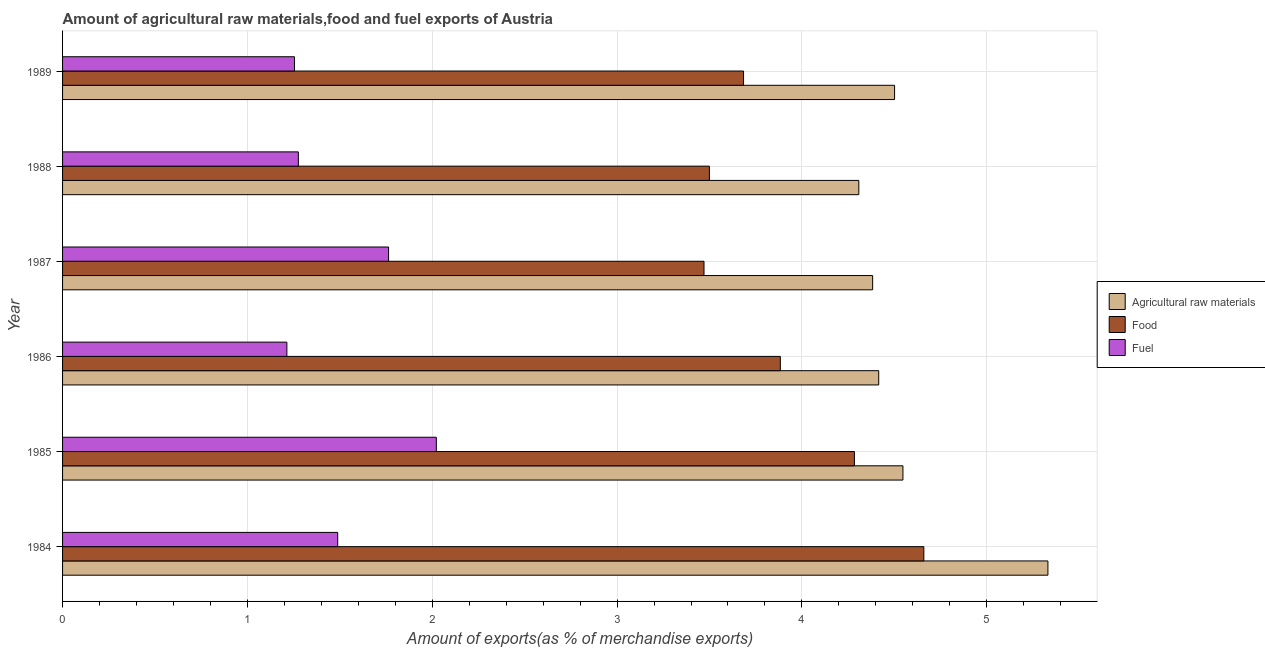How many groups of bars are there?
Offer a very short reply. 6. Are the number of bars per tick equal to the number of legend labels?
Keep it short and to the point. Yes. What is the percentage of raw materials exports in 1986?
Offer a terse response. 4.42. Across all years, what is the maximum percentage of fuel exports?
Give a very brief answer. 2.02. Across all years, what is the minimum percentage of raw materials exports?
Give a very brief answer. 4.31. In which year was the percentage of fuel exports minimum?
Make the answer very short. 1986. What is the total percentage of raw materials exports in the graph?
Make the answer very short. 27.49. What is the difference between the percentage of raw materials exports in 1988 and that in 1989?
Make the answer very short. -0.19. What is the difference between the percentage of raw materials exports in 1985 and the percentage of food exports in 1987?
Ensure brevity in your answer.  1.08. What is the average percentage of raw materials exports per year?
Provide a short and direct response. 4.58. In the year 1987, what is the difference between the percentage of food exports and percentage of raw materials exports?
Your answer should be very brief. -0.91. In how many years, is the percentage of food exports greater than 2.2 %?
Provide a short and direct response. 6. Is the percentage of raw materials exports in 1987 less than that in 1989?
Provide a succinct answer. Yes. Is the difference between the percentage of fuel exports in 1985 and 1988 greater than the difference between the percentage of raw materials exports in 1985 and 1988?
Your answer should be very brief. Yes. What is the difference between the highest and the second highest percentage of fuel exports?
Provide a short and direct response. 0.26. What is the difference between the highest and the lowest percentage of fuel exports?
Provide a succinct answer. 0.81. Is the sum of the percentage of raw materials exports in 1987 and 1988 greater than the maximum percentage of food exports across all years?
Offer a very short reply. Yes. What does the 3rd bar from the top in 1987 represents?
Make the answer very short. Agricultural raw materials. What does the 2nd bar from the bottom in 1987 represents?
Provide a short and direct response. Food. Is it the case that in every year, the sum of the percentage of raw materials exports and percentage of food exports is greater than the percentage of fuel exports?
Keep it short and to the point. Yes. How many bars are there?
Make the answer very short. 18. Are all the bars in the graph horizontal?
Give a very brief answer. Yes. How many years are there in the graph?
Your answer should be very brief. 6. Are the values on the major ticks of X-axis written in scientific E-notation?
Your answer should be compact. No. Where does the legend appear in the graph?
Offer a terse response. Center right. How many legend labels are there?
Give a very brief answer. 3. What is the title of the graph?
Your answer should be very brief. Amount of agricultural raw materials,food and fuel exports of Austria. Does "Male employers" appear as one of the legend labels in the graph?
Provide a short and direct response. No. What is the label or title of the X-axis?
Your answer should be very brief. Amount of exports(as % of merchandise exports). What is the label or title of the Y-axis?
Your answer should be compact. Year. What is the Amount of exports(as % of merchandise exports) in Agricultural raw materials in 1984?
Provide a succinct answer. 5.33. What is the Amount of exports(as % of merchandise exports) in Food in 1984?
Give a very brief answer. 4.66. What is the Amount of exports(as % of merchandise exports) of Fuel in 1984?
Give a very brief answer. 1.49. What is the Amount of exports(as % of merchandise exports) in Agricultural raw materials in 1985?
Ensure brevity in your answer.  4.55. What is the Amount of exports(as % of merchandise exports) of Food in 1985?
Ensure brevity in your answer.  4.28. What is the Amount of exports(as % of merchandise exports) in Fuel in 1985?
Provide a short and direct response. 2.02. What is the Amount of exports(as % of merchandise exports) in Agricultural raw materials in 1986?
Your response must be concise. 4.42. What is the Amount of exports(as % of merchandise exports) in Food in 1986?
Make the answer very short. 3.88. What is the Amount of exports(as % of merchandise exports) in Fuel in 1986?
Offer a terse response. 1.21. What is the Amount of exports(as % of merchandise exports) of Agricultural raw materials in 1987?
Your answer should be compact. 4.38. What is the Amount of exports(as % of merchandise exports) in Food in 1987?
Provide a short and direct response. 3.47. What is the Amount of exports(as % of merchandise exports) in Fuel in 1987?
Give a very brief answer. 1.76. What is the Amount of exports(as % of merchandise exports) of Agricultural raw materials in 1988?
Ensure brevity in your answer.  4.31. What is the Amount of exports(as % of merchandise exports) in Food in 1988?
Offer a terse response. 3.5. What is the Amount of exports(as % of merchandise exports) of Fuel in 1988?
Keep it short and to the point. 1.28. What is the Amount of exports(as % of merchandise exports) in Agricultural raw materials in 1989?
Give a very brief answer. 4.5. What is the Amount of exports(as % of merchandise exports) in Food in 1989?
Offer a very short reply. 3.68. What is the Amount of exports(as % of merchandise exports) in Fuel in 1989?
Offer a terse response. 1.25. Across all years, what is the maximum Amount of exports(as % of merchandise exports) in Agricultural raw materials?
Keep it short and to the point. 5.33. Across all years, what is the maximum Amount of exports(as % of merchandise exports) in Food?
Your answer should be very brief. 4.66. Across all years, what is the maximum Amount of exports(as % of merchandise exports) of Fuel?
Your answer should be compact. 2.02. Across all years, what is the minimum Amount of exports(as % of merchandise exports) of Agricultural raw materials?
Keep it short and to the point. 4.31. Across all years, what is the minimum Amount of exports(as % of merchandise exports) of Food?
Ensure brevity in your answer.  3.47. Across all years, what is the minimum Amount of exports(as % of merchandise exports) of Fuel?
Make the answer very short. 1.21. What is the total Amount of exports(as % of merchandise exports) of Agricultural raw materials in the graph?
Ensure brevity in your answer.  27.49. What is the total Amount of exports(as % of merchandise exports) in Food in the graph?
Your response must be concise. 23.48. What is the total Amount of exports(as % of merchandise exports) in Fuel in the graph?
Your answer should be very brief. 9.02. What is the difference between the Amount of exports(as % of merchandise exports) in Agricultural raw materials in 1984 and that in 1985?
Provide a succinct answer. 0.78. What is the difference between the Amount of exports(as % of merchandise exports) of Food in 1984 and that in 1985?
Make the answer very short. 0.38. What is the difference between the Amount of exports(as % of merchandise exports) in Fuel in 1984 and that in 1985?
Make the answer very short. -0.53. What is the difference between the Amount of exports(as % of merchandise exports) in Agricultural raw materials in 1984 and that in 1986?
Ensure brevity in your answer.  0.92. What is the difference between the Amount of exports(as % of merchandise exports) in Food in 1984 and that in 1986?
Provide a short and direct response. 0.78. What is the difference between the Amount of exports(as % of merchandise exports) of Fuel in 1984 and that in 1986?
Keep it short and to the point. 0.28. What is the difference between the Amount of exports(as % of merchandise exports) in Agricultural raw materials in 1984 and that in 1987?
Your response must be concise. 0.95. What is the difference between the Amount of exports(as % of merchandise exports) of Food in 1984 and that in 1987?
Provide a short and direct response. 1.19. What is the difference between the Amount of exports(as % of merchandise exports) in Fuel in 1984 and that in 1987?
Offer a terse response. -0.28. What is the difference between the Amount of exports(as % of merchandise exports) in Agricultural raw materials in 1984 and that in 1988?
Your answer should be very brief. 1.02. What is the difference between the Amount of exports(as % of merchandise exports) of Food in 1984 and that in 1988?
Provide a short and direct response. 1.16. What is the difference between the Amount of exports(as % of merchandise exports) in Fuel in 1984 and that in 1988?
Your response must be concise. 0.21. What is the difference between the Amount of exports(as % of merchandise exports) of Agricultural raw materials in 1984 and that in 1989?
Provide a short and direct response. 0.83. What is the difference between the Amount of exports(as % of merchandise exports) in Food in 1984 and that in 1989?
Offer a terse response. 0.98. What is the difference between the Amount of exports(as % of merchandise exports) in Fuel in 1984 and that in 1989?
Your answer should be compact. 0.23. What is the difference between the Amount of exports(as % of merchandise exports) of Agricultural raw materials in 1985 and that in 1986?
Provide a short and direct response. 0.13. What is the difference between the Amount of exports(as % of merchandise exports) of Food in 1985 and that in 1986?
Provide a succinct answer. 0.4. What is the difference between the Amount of exports(as % of merchandise exports) in Fuel in 1985 and that in 1986?
Offer a terse response. 0.81. What is the difference between the Amount of exports(as % of merchandise exports) in Agricultural raw materials in 1985 and that in 1987?
Your answer should be very brief. 0.16. What is the difference between the Amount of exports(as % of merchandise exports) in Food in 1985 and that in 1987?
Your answer should be very brief. 0.81. What is the difference between the Amount of exports(as % of merchandise exports) in Fuel in 1985 and that in 1987?
Provide a short and direct response. 0.26. What is the difference between the Amount of exports(as % of merchandise exports) of Agricultural raw materials in 1985 and that in 1988?
Provide a succinct answer. 0.24. What is the difference between the Amount of exports(as % of merchandise exports) in Food in 1985 and that in 1988?
Your answer should be compact. 0.78. What is the difference between the Amount of exports(as % of merchandise exports) of Fuel in 1985 and that in 1988?
Keep it short and to the point. 0.75. What is the difference between the Amount of exports(as % of merchandise exports) in Agricultural raw materials in 1985 and that in 1989?
Provide a short and direct response. 0.05. What is the difference between the Amount of exports(as % of merchandise exports) in Food in 1985 and that in 1989?
Keep it short and to the point. 0.6. What is the difference between the Amount of exports(as % of merchandise exports) of Fuel in 1985 and that in 1989?
Offer a terse response. 0.77. What is the difference between the Amount of exports(as % of merchandise exports) of Agricultural raw materials in 1986 and that in 1987?
Give a very brief answer. 0.03. What is the difference between the Amount of exports(as % of merchandise exports) of Food in 1986 and that in 1987?
Offer a very short reply. 0.41. What is the difference between the Amount of exports(as % of merchandise exports) of Fuel in 1986 and that in 1987?
Your answer should be very brief. -0.55. What is the difference between the Amount of exports(as % of merchandise exports) of Agricultural raw materials in 1986 and that in 1988?
Keep it short and to the point. 0.11. What is the difference between the Amount of exports(as % of merchandise exports) in Food in 1986 and that in 1988?
Ensure brevity in your answer.  0.38. What is the difference between the Amount of exports(as % of merchandise exports) in Fuel in 1986 and that in 1988?
Give a very brief answer. -0.06. What is the difference between the Amount of exports(as % of merchandise exports) in Agricultural raw materials in 1986 and that in 1989?
Your answer should be compact. -0.09. What is the difference between the Amount of exports(as % of merchandise exports) in Food in 1986 and that in 1989?
Your answer should be very brief. 0.2. What is the difference between the Amount of exports(as % of merchandise exports) of Fuel in 1986 and that in 1989?
Your answer should be very brief. -0.04. What is the difference between the Amount of exports(as % of merchandise exports) in Agricultural raw materials in 1987 and that in 1988?
Your response must be concise. 0.07. What is the difference between the Amount of exports(as % of merchandise exports) in Food in 1987 and that in 1988?
Make the answer very short. -0.03. What is the difference between the Amount of exports(as % of merchandise exports) in Fuel in 1987 and that in 1988?
Your answer should be compact. 0.49. What is the difference between the Amount of exports(as % of merchandise exports) of Agricultural raw materials in 1987 and that in 1989?
Offer a very short reply. -0.12. What is the difference between the Amount of exports(as % of merchandise exports) in Food in 1987 and that in 1989?
Provide a short and direct response. -0.21. What is the difference between the Amount of exports(as % of merchandise exports) in Fuel in 1987 and that in 1989?
Offer a very short reply. 0.51. What is the difference between the Amount of exports(as % of merchandise exports) of Agricultural raw materials in 1988 and that in 1989?
Keep it short and to the point. -0.19. What is the difference between the Amount of exports(as % of merchandise exports) of Food in 1988 and that in 1989?
Keep it short and to the point. -0.18. What is the difference between the Amount of exports(as % of merchandise exports) in Fuel in 1988 and that in 1989?
Ensure brevity in your answer.  0.02. What is the difference between the Amount of exports(as % of merchandise exports) in Agricultural raw materials in 1984 and the Amount of exports(as % of merchandise exports) in Food in 1985?
Offer a terse response. 1.05. What is the difference between the Amount of exports(as % of merchandise exports) of Agricultural raw materials in 1984 and the Amount of exports(as % of merchandise exports) of Fuel in 1985?
Your response must be concise. 3.31. What is the difference between the Amount of exports(as % of merchandise exports) in Food in 1984 and the Amount of exports(as % of merchandise exports) in Fuel in 1985?
Give a very brief answer. 2.64. What is the difference between the Amount of exports(as % of merchandise exports) of Agricultural raw materials in 1984 and the Amount of exports(as % of merchandise exports) of Food in 1986?
Keep it short and to the point. 1.45. What is the difference between the Amount of exports(as % of merchandise exports) of Agricultural raw materials in 1984 and the Amount of exports(as % of merchandise exports) of Fuel in 1986?
Provide a succinct answer. 4.12. What is the difference between the Amount of exports(as % of merchandise exports) in Food in 1984 and the Amount of exports(as % of merchandise exports) in Fuel in 1986?
Give a very brief answer. 3.45. What is the difference between the Amount of exports(as % of merchandise exports) in Agricultural raw materials in 1984 and the Amount of exports(as % of merchandise exports) in Food in 1987?
Offer a terse response. 1.86. What is the difference between the Amount of exports(as % of merchandise exports) in Agricultural raw materials in 1984 and the Amount of exports(as % of merchandise exports) in Fuel in 1987?
Your answer should be very brief. 3.57. What is the difference between the Amount of exports(as % of merchandise exports) in Food in 1984 and the Amount of exports(as % of merchandise exports) in Fuel in 1987?
Give a very brief answer. 2.9. What is the difference between the Amount of exports(as % of merchandise exports) in Agricultural raw materials in 1984 and the Amount of exports(as % of merchandise exports) in Food in 1988?
Give a very brief answer. 1.83. What is the difference between the Amount of exports(as % of merchandise exports) in Agricultural raw materials in 1984 and the Amount of exports(as % of merchandise exports) in Fuel in 1988?
Your response must be concise. 4.06. What is the difference between the Amount of exports(as % of merchandise exports) of Food in 1984 and the Amount of exports(as % of merchandise exports) of Fuel in 1988?
Offer a very short reply. 3.38. What is the difference between the Amount of exports(as % of merchandise exports) in Agricultural raw materials in 1984 and the Amount of exports(as % of merchandise exports) in Food in 1989?
Keep it short and to the point. 1.65. What is the difference between the Amount of exports(as % of merchandise exports) in Agricultural raw materials in 1984 and the Amount of exports(as % of merchandise exports) in Fuel in 1989?
Ensure brevity in your answer.  4.08. What is the difference between the Amount of exports(as % of merchandise exports) of Food in 1984 and the Amount of exports(as % of merchandise exports) of Fuel in 1989?
Provide a short and direct response. 3.4. What is the difference between the Amount of exports(as % of merchandise exports) in Agricultural raw materials in 1985 and the Amount of exports(as % of merchandise exports) in Food in 1986?
Make the answer very short. 0.66. What is the difference between the Amount of exports(as % of merchandise exports) of Agricultural raw materials in 1985 and the Amount of exports(as % of merchandise exports) of Fuel in 1986?
Your answer should be very brief. 3.33. What is the difference between the Amount of exports(as % of merchandise exports) of Food in 1985 and the Amount of exports(as % of merchandise exports) of Fuel in 1986?
Offer a terse response. 3.07. What is the difference between the Amount of exports(as % of merchandise exports) of Agricultural raw materials in 1985 and the Amount of exports(as % of merchandise exports) of Food in 1987?
Give a very brief answer. 1.08. What is the difference between the Amount of exports(as % of merchandise exports) of Agricultural raw materials in 1985 and the Amount of exports(as % of merchandise exports) of Fuel in 1987?
Your answer should be very brief. 2.78. What is the difference between the Amount of exports(as % of merchandise exports) of Food in 1985 and the Amount of exports(as % of merchandise exports) of Fuel in 1987?
Your answer should be very brief. 2.52. What is the difference between the Amount of exports(as % of merchandise exports) of Agricultural raw materials in 1985 and the Amount of exports(as % of merchandise exports) of Food in 1988?
Your answer should be compact. 1.05. What is the difference between the Amount of exports(as % of merchandise exports) in Agricultural raw materials in 1985 and the Amount of exports(as % of merchandise exports) in Fuel in 1988?
Your answer should be compact. 3.27. What is the difference between the Amount of exports(as % of merchandise exports) in Food in 1985 and the Amount of exports(as % of merchandise exports) in Fuel in 1988?
Give a very brief answer. 3.01. What is the difference between the Amount of exports(as % of merchandise exports) in Agricultural raw materials in 1985 and the Amount of exports(as % of merchandise exports) in Food in 1989?
Your response must be concise. 0.86. What is the difference between the Amount of exports(as % of merchandise exports) in Agricultural raw materials in 1985 and the Amount of exports(as % of merchandise exports) in Fuel in 1989?
Make the answer very short. 3.29. What is the difference between the Amount of exports(as % of merchandise exports) of Food in 1985 and the Amount of exports(as % of merchandise exports) of Fuel in 1989?
Your response must be concise. 3.03. What is the difference between the Amount of exports(as % of merchandise exports) in Agricultural raw materials in 1986 and the Amount of exports(as % of merchandise exports) in Food in 1987?
Ensure brevity in your answer.  0.95. What is the difference between the Amount of exports(as % of merchandise exports) of Agricultural raw materials in 1986 and the Amount of exports(as % of merchandise exports) of Fuel in 1987?
Ensure brevity in your answer.  2.65. What is the difference between the Amount of exports(as % of merchandise exports) of Food in 1986 and the Amount of exports(as % of merchandise exports) of Fuel in 1987?
Your answer should be compact. 2.12. What is the difference between the Amount of exports(as % of merchandise exports) of Agricultural raw materials in 1986 and the Amount of exports(as % of merchandise exports) of Food in 1988?
Keep it short and to the point. 0.92. What is the difference between the Amount of exports(as % of merchandise exports) of Agricultural raw materials in 1986 and the Amount of exports(as % of merchandise exports) of Fuel in 1988?
Give a very brief answer. 3.14. What is the difference between the Amount of exports(as % of merchandise exports) in Food in 1986 and the Amount of exports(as % of merchandise exports) in Fuel in 1988?
Offer a terse response. 2.61. What is the difference between the Amount of exports(as % of merchandise exports) of Agricultural raw materials in 1986 and the Amount of exports(as % of merchandise exports) of Food in 1989?
Give a very brief answer. 0.73. What is the difference between the Amount of exports(as % of merchandise exports) of Agricultural raw materials in 1986 and the Amount of exports(as % of merchandise exports) of Fuel in 1989?
Make the answer very short. 3.16. What is the difference between the Amount of exports(as % of merchandise exports) of Food in 1986 and the Amount of exports(as % of merchandise exports) of Fuel in 1989?
Provide a short and direct response. 2.63. What is the difference between the Amount of exports(as % of merchandise exports) in Agricultural raw materials in 1987 and the Amount of exports(as % of merchandise exports) in Food in 1988?
Provide a short and direct response. 0.88. What is the difference between the Amount of exports(as % of merchandise exports) of Agricultural raw materials in 1987 and the Amount of exports(as % of merchandise exports) of Fuel in 1988?
Offer a very short reply. 3.11. What is the difference between the Amount of exports(as % of merchandise exports) of Food in 1987 and the Amount of exports(as % of merchandise exports) of Fuel in 1988?
Make the answer very short. 2.19. What is the difference between the Amount of exports(as % of merchandise exports) in Agricultural raw materials in 1987 and the Amount of exports(as % of merchandise exports) in Food in 1989?
Your answer should be compact. 0.7. What is the difference between the Amount of exports(as % of merchandise exports) of Agricultural raw materials in 1987 and the Amount of exports(as % of merchandise exports) of Fuel in 1989?
Your response must be concise. 3.13. What is the difference between the Amount of exports(as % of merchandise exports) of Food in 1987 and the Amount of exports(as % of merchandise exports) of Fuel in 1989?
Provide a short and direct response. 2.22. What is the difference between the Amount of exports(as % of merchandise exports) of Agricultural raw materials in 1988 and the Amount of exports(as % of merchandise exports) of Food in 1989?
Make the answer very short. 0.62. What is the difference between the Amount of exports(as % of merchandise exports) in Agricultural raw materials in 1988 and the Amount of exports(as % of merchandise exports) in Fuel in 1989?
Offer a terse response. 3.05. What is the difference between the Amount of exports(as % of merchandise exports) in Food in 1988 and the Amount of exports(as % of merchandise exports) in Fuel in 1989?
Give a very brief answer. 2.24. What is the average Amount of exports(as % of merchandise exports) in Agricultural raw materials per year?
Make the answer very short. 4.58. What is the average Amount of exports(as % of merchandise exports) of Food per year?
Offer a terse response. 3.91. What is the average Amount of exports(as % of merchandise exports) in Fuel per year?
Give a very brief answer. 1.5. In the year 1984, what is the difference between the Amount of exports(as % of merchandise exports) of Agricultural raw materials and Amount of exports(as % of merchandise exports) of Food?
Offer a very short reply. 0.67. In the year 1984, what is the difference between the Amount of exports(as % of merchandise exports) of Agricultural raw materials and Amount of exports(as % of merchandise exports) of Fuel?
Offer a terse response. 3.84. In the year 1984, what is the difference between the Amount of exports(as % of merchandise exports) in Food and Amount of exports(as % of merchandise exports) in Fuel?
Offer a very short reply. 3.17. In the year 1985, what is the difference between the Amount of exports(as % of merchandise exports) in Agricultural raw materials and Amount of exports(as % of merchandise exports) in Food?
Offer a very short reply. 0.26. In the year 1985, what is the difference between the Amount of exports(as % of merchandise exports) of Agricultural raw materials and Amount of exports(as % of merchandise exports) of Fuel?
Provide a succinct answer. 2.52. In the year 1985, what is the difference between the Amount of exports(as % of merchandise exports) in Food and Amount of exports(as % of merchandise exports) in Fuel?
Give a very brief answer. 2.26. In the year 1986, what is the difference between the Amount of exports(as % of merchandise exports) of Agricultural raw materials and Amount of exports(as % of merchandise exports) of Food?
Offer a very short reply. 0.53. In the year 1986, what is the difference between the Amount of exports(as % of merchandise exports) of Agricultural raw materials and Amount of exports(as % of merchandise exports) of Fuel?
Make the answer very short. 3.2. In the year 1986, what is the difference between the Amount of exports(as % of merchandise exports) of Food and Amount of exports(as % of merchandise exports) of Fuel?
Offer a terse response. 2.67. In the year 1987, what is the difference between the Amount of exports(as % of merchandise exports) in Agricultural raw materials and Amount of exports(as % of merchandise exports) in Food?
Give a very brief answer. 0.91. In the year 1987, what is the difference between the Amount of exports(as % of merchandise exports) in Agricultural raw materials and Amount of exports(as % of merchandise exports) in Fuel?
Provide a short and direct response. 2.62. In the year 1987, what is the difference between the Amount of exports(as % of merchandise exports) in Food and Amount of exports(as % of merchandise exports) in Fuel?
Make the answer very short. 1.71. In the year 1988, what is the difference between the Amount of exports(as % of merchandise exports) of Agricultural raw materials and Amount of exports(as % of merchandise exports) of Food?
Offer a terse response. 0.81. In the year 1988, what is the difference between the Amount of exports(as % of merchandise exports) of Agricultural raw materials and Amount of exports(as % of merchandise exports) of Fuel?
Offer a terse response. 3.03. In the year 1988, what is the difference between the Amount of exports(as % of merchandise exports) in Food and Amount of exports(as % of merchandise exports) in Fuel?
Your answer should be compact. 2.22. In the year 1989, what is the difference between the Amount of exports(as % of merchandise exports) in Agricultural raw materials and Amount of exports(as % of merchandise exports) in Food?
Make the answer very short. 0.82. In the year 1989, what is the difference between the Amount of exports(as % of merchandise exports) in Agricultural raw materials and Amount of exports(as % of merchandise exports) in Fuel?
Your answer should be compact. 3.25. In the year 1989, what is the difference between the Amount of exports(as % of merchandise exports) in Food and Amount of exports(as % of merchandise exports) in Fuel?
Provide a short and direct response. 2.43. What is the ratio of the Amount of exports(as % of merchandise exports) of Agricultural raw materials in 1984 to that in 1985?
Offer a terse response. 1.17. What is the ratio of the Amount of exports(as % of merchandise exports) in Food in 1984 to that in 1985?
Provide a succinct answer. 1.09. What is the ratio of the Amount of exports(as % of merchandise exports) of Fuel in 1984 to that in 1985?
Give a very brief answer. 0.74. What is the ratio of the Amount of exports(as % of merchandise exports) in Agricultural raw materials in 1984 to that in 1986?
Ensure brevity in your answer.  1.21. What is the ratio of the Amount of exports(as % of merchandise exports) of Food in 1984 to that in 1986?
Give a very brief answer. 1.2. What is the ratio of the Amount of exports(as % of merchandise exports) of Fuel in 1984 to that in 1986?
Keep it short and to the point. 1.23. What is the ratio of the Amount of exports(as % of merchandise exports) in Agricultural raw materials in 1984 to that in 1987?
Keep it short and to the point. 1.22. What is the ratio of the Amount of exports(as % of merchandise exports) in Food in 1984 to that in 1987?
Make the answer very short. 1.34. What is the ratio of the Amount of exports(as % of merchandise exports) of Fuel in 1984 to that in 1987?
Offer a very short reply. 0.84. What is the ratio of the Amount of exports(as % of merchandise exports) in Agricultural raw materials in 1984 to that in 1988?
Provide a succinct answer. 1.24. What is the ratio of the Amount of exports(as % of merchandise exports) in Food in 1984 to that in 1988?
Keep it short and to the point. 1.33. What is the ratio of the Amount of exports(as % of merchandise exports) in Fuel in 1984 to that in 1988?
Your answer should be compact. 1.17. What is the ratio of the Amount of exports(as % of merchandise exports) in Agricultural raw materials in 1984 to that in 1989?
Offer a terse response. 1.18. What is the ratio of the Amount of exports(as % of merchandise exports) in Food in 1984 to that in 1989?
Your response must be concise. 1.26. What is the ratio of the Amount of exports(as % of merchandise exports) of Fuel in 1984 to that in 1989?
Offer a very short reply. 1.19. What is the ratio of the Amount of exports(as % of merchandise exports) in Agricultural raw materials in 1985 to that in 1986?
Your response must be concise. 1.03. What is the ratio of the Amount of exports(as % of merchandise exports) in Food in 1985 to that in 1986?
Keep it short and to the point. 1.1. What is the ratio of the Amount of exports(as % of merchandise exports) of Fuel in 1985 to that in 1986?
Keep it short and to the point. 1.67. What is the ratio of the Amount of exports(as % of merchandise exports) of Agricultural raw materials in 1985 to that in 1987?
Offer a terse response. 1.04. What is the ratio of the Amount of exports(as % of merchandise exports) in Food in 1985 to that in 1987?
Your answer should be very brief. 1.23. What is the ratio of the Amount of exports(as % of merchandise exports) of Fuel in 1985 to that in 1987?
Your answer should be very brief. 1.15. What is the ratio of the Amount of exports(as % of merchandise exports) of Agricultural raw materials in 1985 to that in 1988?
Ensure brevity in your answer.  1.06. What is the ratio of the Amount of exports(as % of merchandise exports) of Food in 1985 to that in 1988?
Give a very brief answer. 1.22. What is the ratio of the Amount of exports(as % of merchandise exports) in Fuel in 1985 to that in 1988?
Your answer should be compact. 1.59. What is the ratio of the Amount of exports(as % of merchandise exports) of Food in 1985 to that in 1989?
Give a very brief answer. 1.16. What is the ratio of the Amount of exports(as % of merchandise exports) of Fuel in 1985 to that in 1989?
Provide a succinct answer. 1.61. What is the ratio of the Amount of exports(as % of merchandise exports) in Agricultural raw materials in 1986 to that in 1987?
Your response must be concise. 1.01. What is the ratio of the Amount of exports(as % of merchandise exports) of Food in 1986 to that in 1987?
Give a very brief answer. 1.12. What is the ratio of the Amount of exports(as % of merchandise exports) of Fuel in 1986 to that in 1987?
Your answer should be very brief. 0.69. What is the ratio of the Amount of exports(as % of merchandise exports) in Agricultural raw materials in 1986 to that in 1988?
Provide a short and direct response. 1.02. What is the ratio of the Amount of exports(as % of merchandise exports) in Food in 1986 to that in 1988?
Make the answer very short. 1.11. What is the ratio of the Amount of exports(as % of merchandise exports) of Fuel in 1986 to that in 1988?
Your answer should be very brief. 0.95. What is the ratio of the Amount of exports(as % of merchandise exports) of Agricultural raw materials in 1986 to that in 1989?
Provide a succinct answer. 0.98. What is the ratio of the Amount of exports(as % of merchandise exports) of Food in 1986 to that in 1989?
Keep it short and to the point. 1.05. What is the ratio of the Amount of exports(as % of merchandise exports) in Fuel in 1986 to that in 1989?
Make the answer very short. 0.97. What is the ratio of the Amount of exports(as % of merchandise exports) of Agricultural raw materials in 1987 to that in 1988?
Offer a terse response. 1.02. What is the ratio of the Amount of exports(as % of merchandise exports) of Fuel in 1987 to that in 1988?
Provide a short and direct response. 1.38. What is the ratio of the Amount of exports(as % of merchandise exports) of Agricultural raw materials in 1987 to that in 1989?
Your answer should be very brief. 0.97. What is the ratio of the Amount of exports(as % of merchandise exports) in Food in 1987 to that in 1989?
Provide a short and direct response. 0.94. What is the ratio of the Amount of exports(as % of merchandise exports) in Fuel in 1987 to that in 1989?
Make the answer very short. 1.41. What is the ratio of the Amount of exports(as % of merchandise exports) in Agricultural raw materials in 1988 to that in 1989?
Provide a succinct answer. 0.96. What is the ratio of the Amount of exports(as % of merchandise exports) of Food in 1988 to that in 1989?
Make the answer very short. 0.95. What is the ratio of the Amount of exports(as % of merchandise exports) in Fuel in 1988 to that in 1989?
Provide a succinct answer. 1.02. What is the difference between the highest and the second highest Amount of exports(as % of merchandise exports) in Agricultural raw materials?
Provide a succinct answer. 0.78. What is the difference between the highest and the second highest Amount of exports(as % of merchandise exports) of Food?
Give a very brief answer. 0.38. What is the difference between the highest and the second highest Amount of exports(as % of merchandise exports) in Fuel?
Your response must be concise. 0.26. What is the difference between the highest and the lowest Amount of exports(as % of merchandise exports) of Agricultural raw materials?
Provide a short and direct response. 1.02. What is the difference between the highest and the lowest Amount of exports(as % of merchandise exports) in Food?
Your response must be concise. 1.19. What is the difference between the highest and the lowest Amount of exports(as % of merchandise exports) in Fuel?
Ensure brevity in your answer.  0.81. 